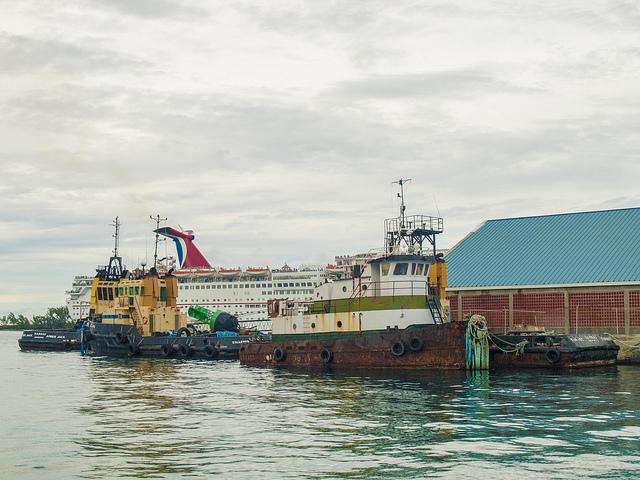Are people who operate these vehicles expected to have licenses?
Concise answer only. Yes. Is the boat on the right rusting?
Answer briefly. Yes. What color is the roof of the building?
Quick response, please. Blue. How many boats are docked at this pier?
Keep it brief. 3. 